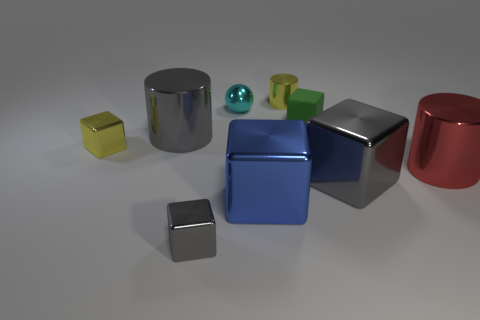Subtract all small shiny cubes. How many cubes are left? 3 Subtract 1 cylinders. How many cylinders are left? 2 Subtract all blue blocks. How many blocks are left? 4 Subtract all spheres. How many objects are left? 8 Subtract all big blue metal blocks. Subtract all small yellow things. How many objects are left? 6 Add 6 red cylinders. How many red cylinders are left? 7 Add 4 tiny blocks. How many tiny blocks exist? 7 Subtract 0 green balls. How many objects are left? 9 Subtract all green spheres. Subtract all gray cylinders. How many spheres are left? 1 Subtract all red cylinders. How many yellow spheres are left? 0 